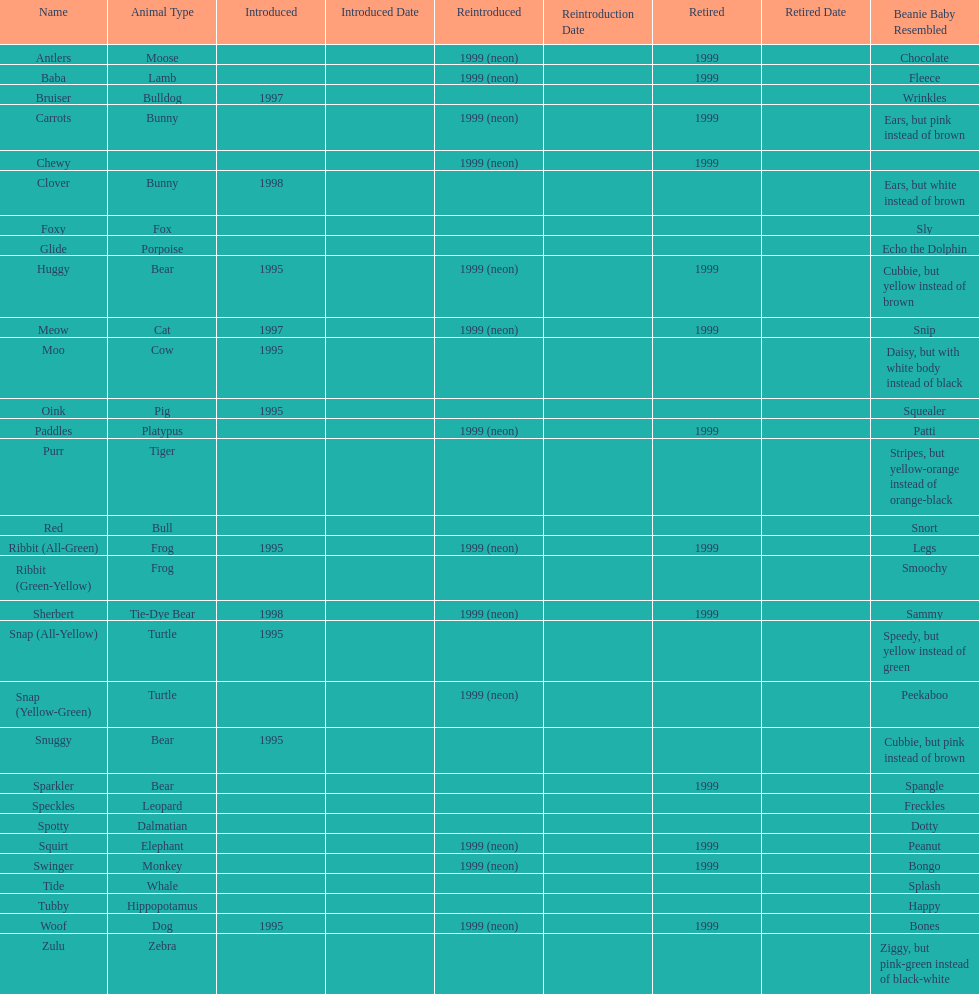Which animal type has the most pillow pals? Bear. 